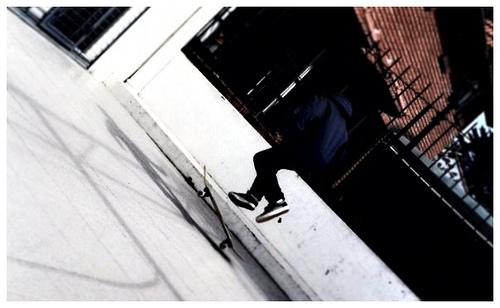Is the person inside or outside?
Write a very short answer. Outside. Are his feet touching the floor?
Short answer required. No. What is he doing?
Short answer required. Skateboarding. 